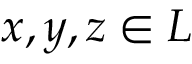Convert formula to latex. <formula><loc_0><loc_0><loc_500><loc_500>x , y , z \in L</formula> 